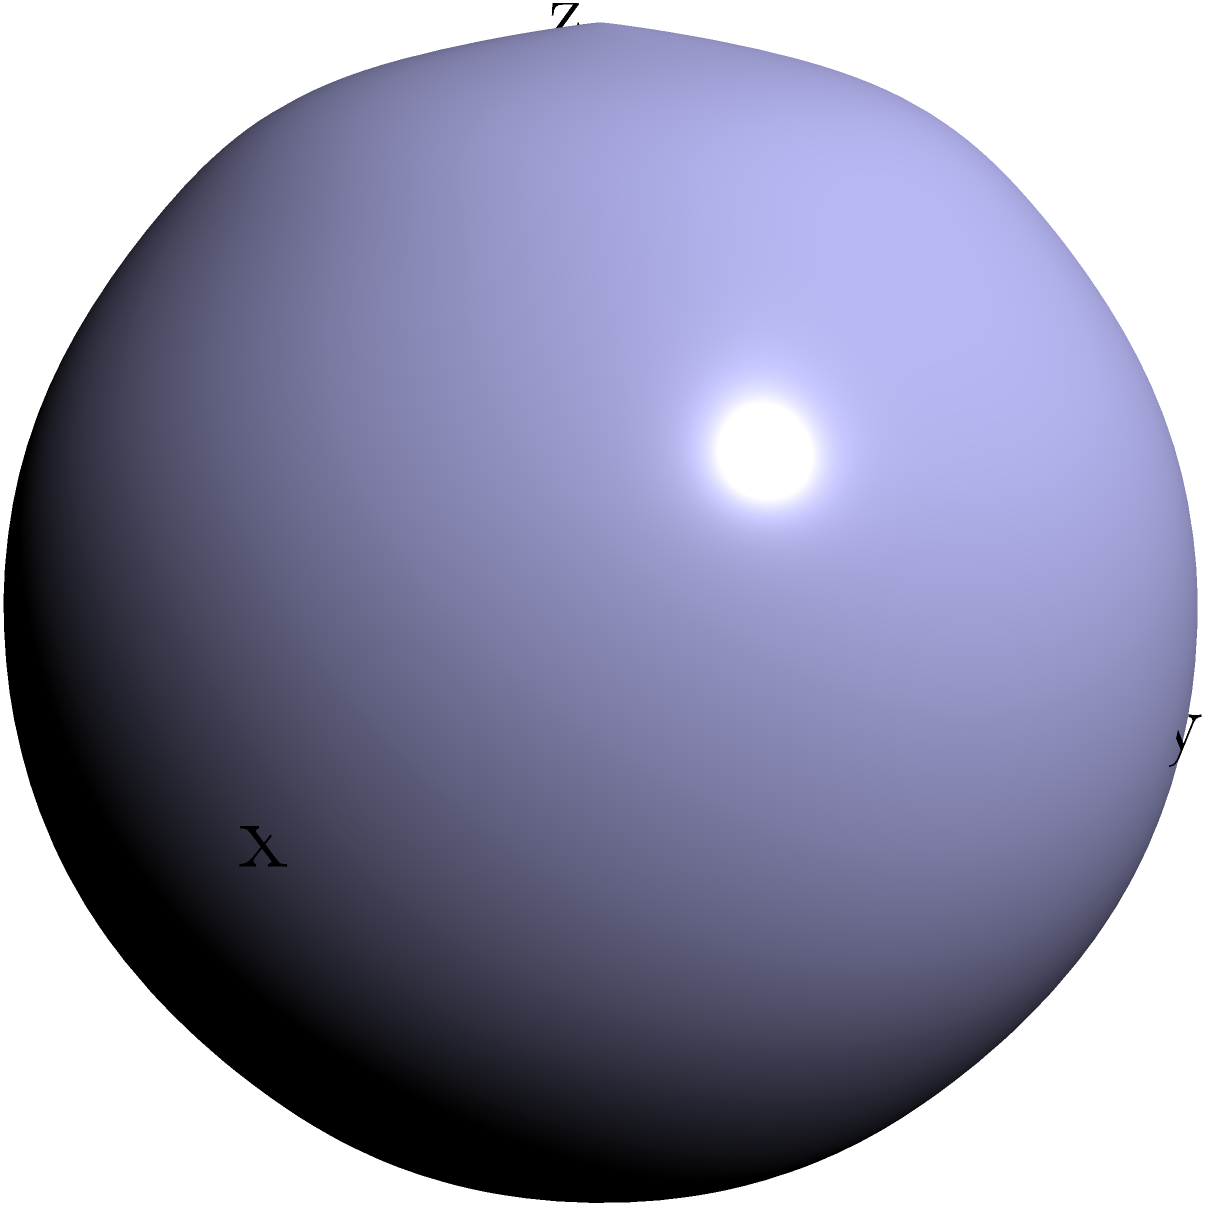The 3D model above represents the oral cavity during the pronunciation of a specific vowel. The surface is defined by the parametric equations:

$$x = 2\cos(u)\sin(v)$$
$$y = 2\sin(u)\sin(v)$$
$$z = 2\cos(v)$$

Where $0 \leq u \leq 2\pi$ and $0 \leq v \leq \pi$. Calculate the volume enclosed by this surface. To calculate the volume enclosed by this surface, we need to use triple integration. Here's the step-by-step process:

1) The volume is given by the triple integral:
   $$V = \iiint_V dV$$

2) For a surface defined parametrically, we can use the formula:
   $$V = \int_0^{2\pi} \int_0^{\pi} \int_0^r r^2 \sin(v) \, dr \, dv \, du$$
   Where $r$ is the distance from the origin to a point on the surface.

3) In our case, $r = 2$ (constant), so we can simplify:
   $$V = \int_0^{2\pi} \int_0^{\pi} \int_0^2 r^2 \sin(v) \, dr \, dv \, du$$

4) Evaluate the inner integral:
   $$V = \int_0^{2\pi} \int_0^{\pi} [\frac{1}{3}r^3]_0^2 \sin(v) \, dv \, du$$
   $$V = \frac{8}{3} \int_0^{2\pi} \int_0^{\pi} \sin(v) \, dv \, du$$

5) Evaluate the middle integral:
   $$V = \frac{8}{3} \int_0^{2\pi} [-\cos(v)]_0^{\pi} \, du$$
   $$V = \frac{8}{3} \int_0^{2\pi} 2 \, du$$

6) Evaluate the outer integral:
   $$V = \frac{16}{3} [u]_0^{2\pi}$$
   $$V = \frac{16}{3} (2\pi - 0)$$
   $$V = \frac{32\pi}{3}$$

Therefore, the volume enclosed by the surface is $\frac{32\pi}{3}$ cubic units.
Answer: $\frac{32\pi}{3}$ cubic units 